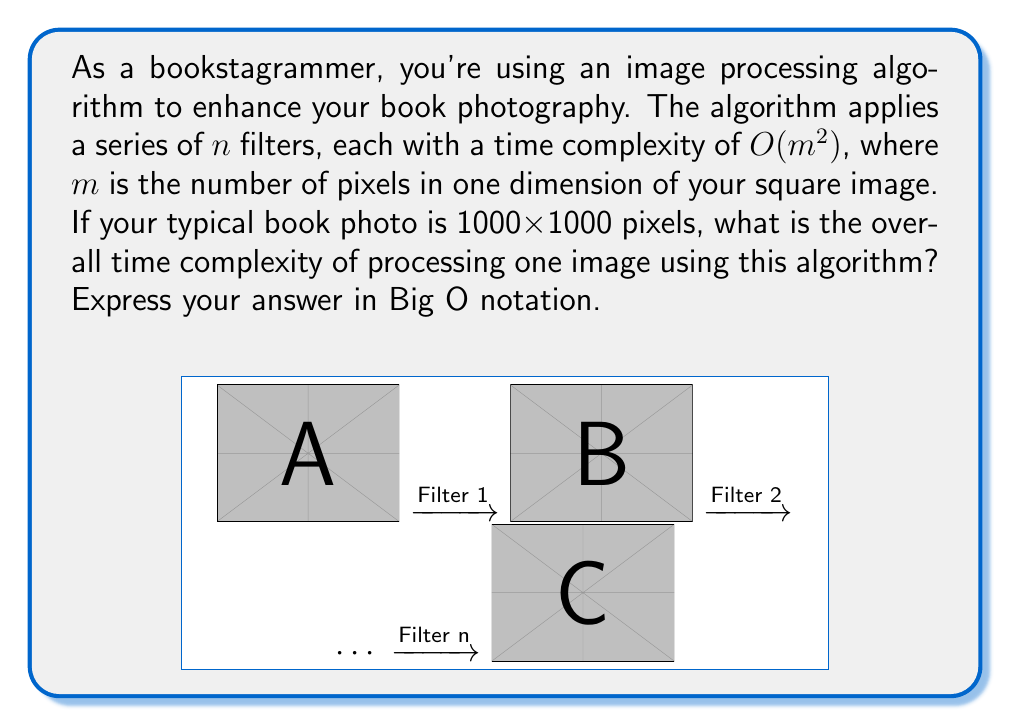Can you answer this question? Let's break this down step-by-step:

1) First, we need to understand the given information:
   - The image is square, with dimensions 1000x1000 pixels
   - There are $n$ filters applied
   - Each filter has a time complexity of $O(m^2)$, where $m$ is the number of pixels in one dimension

2) In this case, $m = 1000$, as the image is 1000x1000 pixels.

3) For a single filter, the time complexity is $O(m^2) = O(1000^2) = O(1,000,000)$

4) However, we're not asked about a single filter, but about $n$ filters applied sequentially.

5) When we have $n$ operations, each with a time complexity of $O(m^2)$, the overall time complexity becomes:

   $$O(n \cdot m^2)$$

6) Substituting $m = 1000$:

   $$O(n \cdot 1000^2) = O(1,000,000n)$$

7) In Big O notation, we drop constant factors, no matter how large. Therefore, our final time complexity is:

   $$O(n)$$

This means the time complexity grows linearly with the number of filters applied, regardless of the image size (as long as the image size remains constant).
Answer: $O(n)$ 